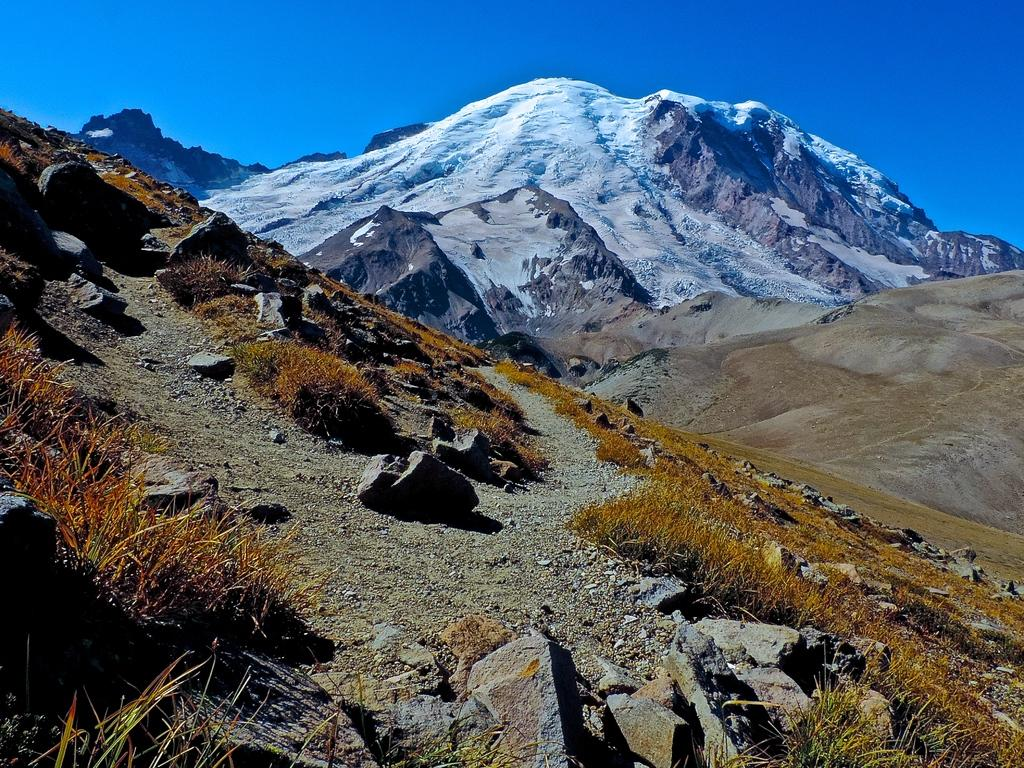What type of terrain is visible at the front of the image? There is a hill with rocks, grass, and small stones in the image. What is the location of the hill in the image? The hill is located at the front of the image. What can be seen behind the hill in the image? There are mountains behind the hill. What is visible at the top of the image? The sky is visible at the top of the image. What type of cake is being served on the hill in the image? There is no cake present in the image; it features a hill with rocks, grass, and small stones, along with mountains in the background. 